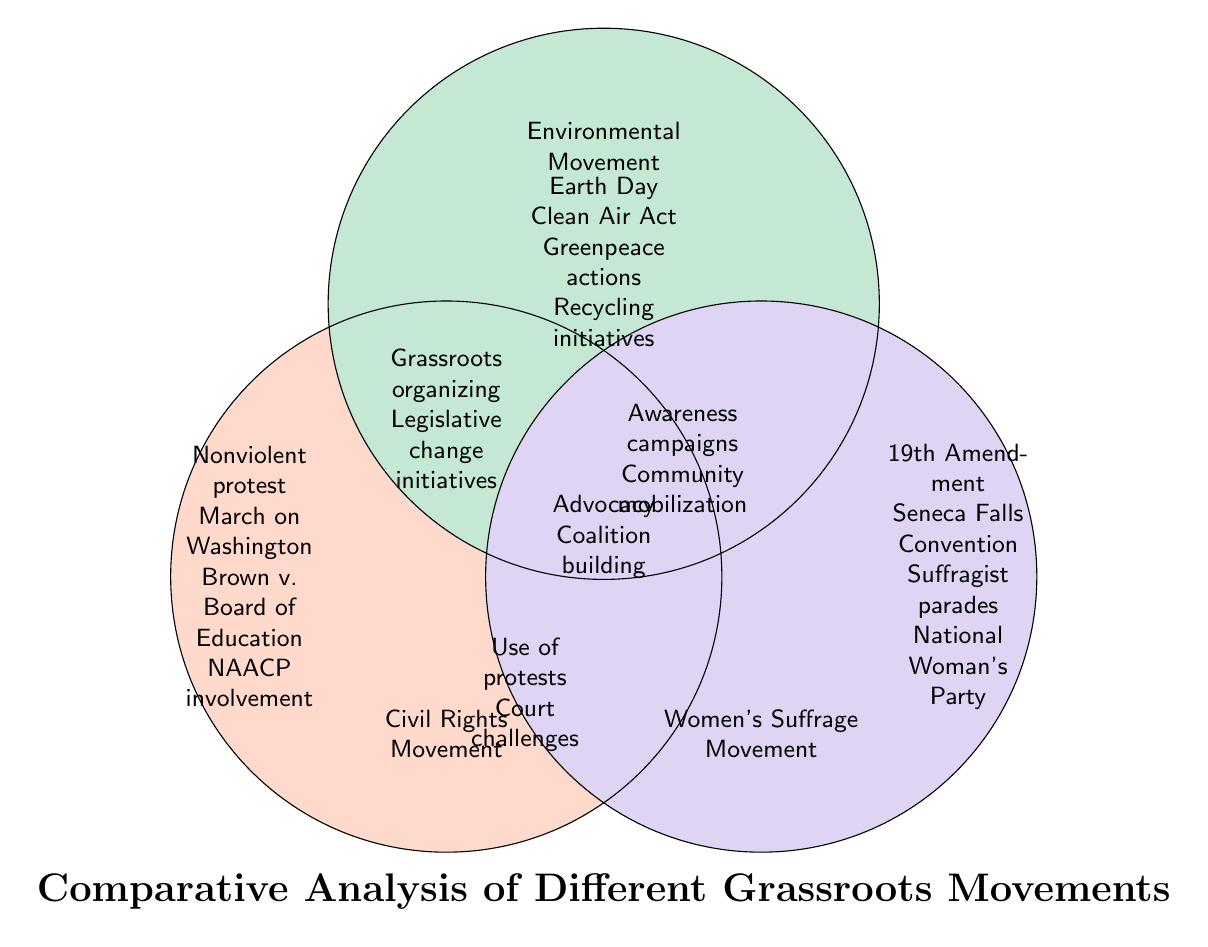What are the three movements represented in the diagram? The diagram shows three distinct circles representing the Civil Rights Movement, Environmental Movement, and Women's Suffrage Movement. Each title is clearly labeled within its respective circle in the diagram.
Answer: Civil Rights Movement, Environmental Movement, Women's Suffrage Movement What event is associated with the Civil Rights Movement? The diagram lists specific events related to each movement. For the Civil Rights Movement, "March on Washington" is mentioned in the non-overlapping area of its circle.
Answer: March on Washington Which movement is associated with the 19th Amendment? Within the Women's Suffrage Movement circle, the "19th Amendment" is explicitly mentioned, indicating its association with this movement.
Answer: 19th Amendment What type of advocacy is shared between the Civil Rights and Women’s Suffrage movements? The overlapping area between the Civil Rights Movement and Women's Suffrage Movement includes "Advocacy," suggesting that both movements employed strategies to promote their causes through advocacy efforts.
Answer: Advocacy What is a shared initiative between the Environmental Movement and Civil Rights Movement? In the overlapping area between the Environmental Movement and Civil Rights Movement, "Use of protests" is listed, indicating that both movements utilized protest as a strategy in their efforts.
Answer: Use of protests How many main areas of activism are highlighted in the diagram? The diagram contains three distinct circles representing three main movements, indicating that there are three main areas of activism being compared.
Answer: 3 What legislative action is mentioned in the Environmental Movement? Looking at the Environmental Movement's circle, "Clean Air Act" is specified, indicating a legislative initiative relevant to this movement.
Answer: Clean Air Act Which movement's actions include "Earth Day" as a significant event? The "Earth Day" event is specifically listed within the Environmental Movement's circle, indicating its importance to this movement.
Answer: Environmental Movement What type of organizing is identified as a common strategy among all three movements? The diagram shows "Grassroots organizing" in the center where all three circles overlap, indicating that this is a common strategy shared by all three movements.
Answer: Grassroots organizing 